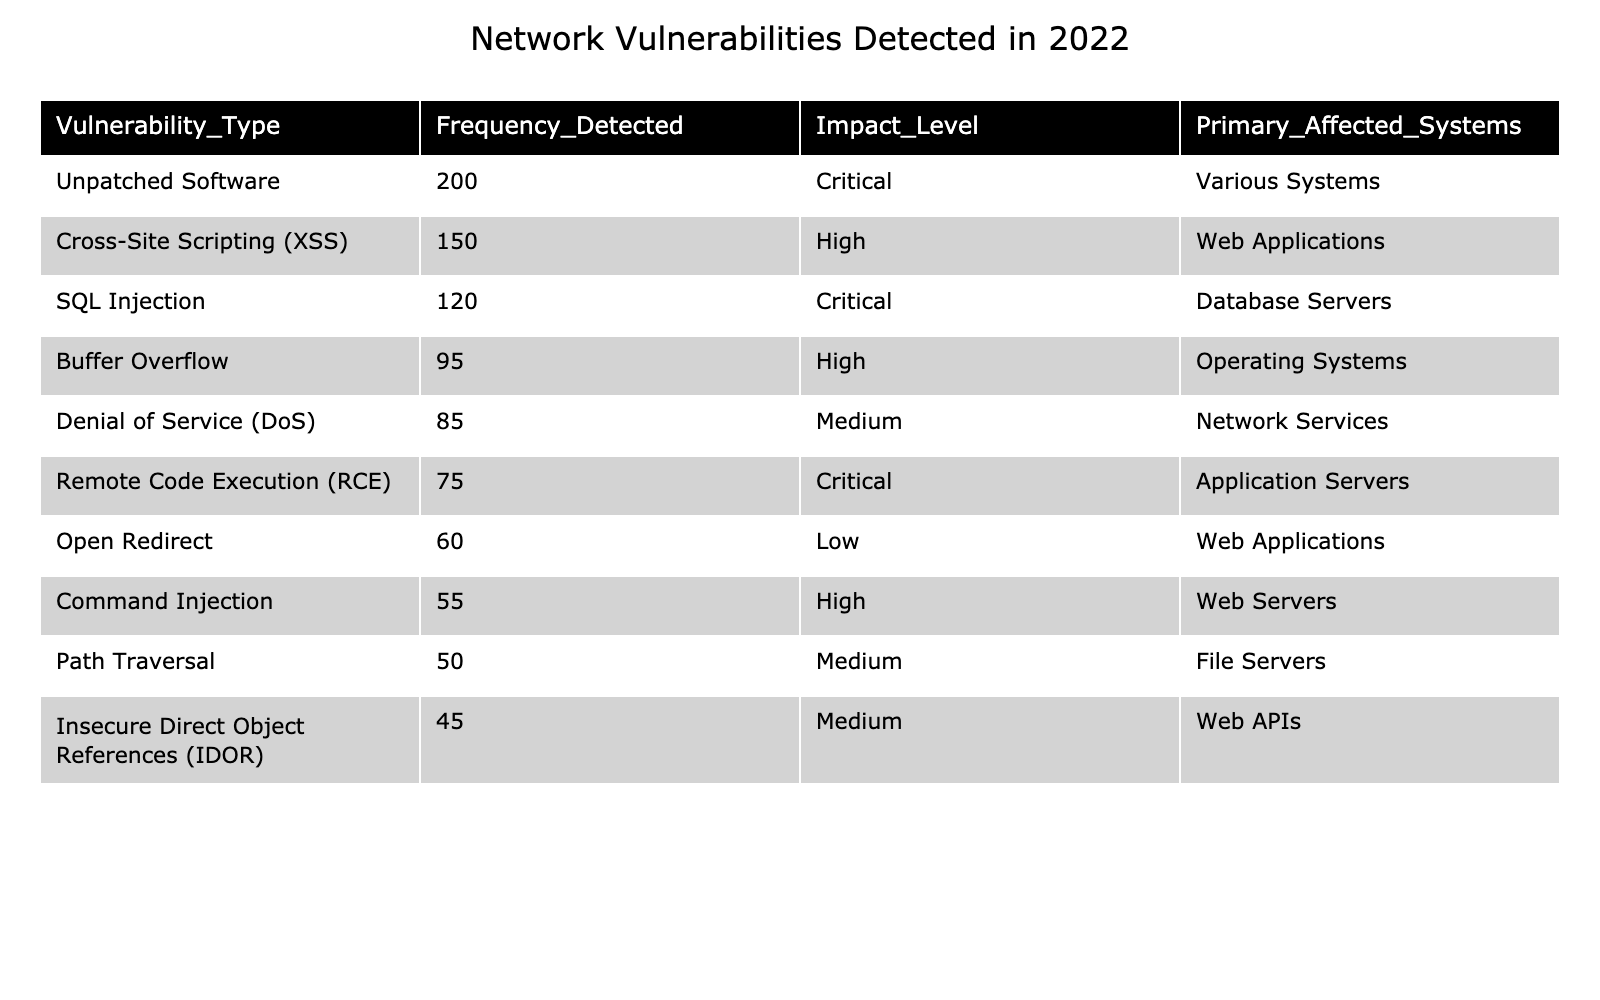What is the type of vulnerability with the highest frequency detected? The highest frequency detected in the table is for "Unpatched Software" with a count of 200. This can be identified by looking at the "Frequency_Detected" column.
Answer: Unpatched Software How many SQL Injection vulnerabilities were detected? The table directly shows that the frequency of SQL Injection vulnerabilities detected is 120.
Answer: 120 What is the average frequency of high-impact vulnerabilities? The high-impact vulnerabilities are XSS (150), Buffer Overflow (95), and Command Injection (55). The total is 150 + 95 + 55 = 300. The average is then 300/3 = 100.
Answer: 100 Is there any vulnerability with a low impact level? Yes, "Open Redirect" is identified in the table as having a low impact level. This can be confirmed by checking the "Impact_Level" column for the corresponding frequency.
Answer: Yes How many more vulnerabilities were detected for Unpatched Software compared to Denial of Service? "Unpatched Software" had 200 detections while "Denial of Service" had 85. The difference is 200 - 85 = 115.
Answer: 115 What proportion of vulnerabilities detected are critical? The critical vulnerabilities are SQL Injection (120), Remote Code Execution (75), and Unpatched Software (200), totaling 395. The total number of vulnerabilities is 200 + 150 + 120 + 95 + 85 + 75 + 60 + 55 + 50 + 45 = 975. The proportion is 395/975 ≈ 0.405, or about 40.5%.
Answer: Approximately 40.5% Which type of vulnerability is primarily affecting web applications? The types of vulnerabilities affecting web applications are "Cross-Site Scripting (XSS)" and "Open Redirect". The presence of these entries in the "Primary_Affected_Systems" column confirms this.
Answer: Cross-Site Scripting (XSS) and Open Redirect What is the total frequency of medium-impact vulnerabilities detected? The medium-impact vulnerabilities listed are Denial of Service (85), Path Traversal (50), and Insecure Direct Object References (45). Their total frequency is 85 + 50 + 45 = 180.
Answer: 180 Which impact level has the lowest total count of detected vulnerabilities? The "Low" impact level has only "Open Redirect" with a frequency of 60. By examining the "Impact_Level" and "Frequency_Detected", this is clear.
Answer: Low What is the difference between the highest and lowest frequency detected among all vulnerabilities? The highest frequency is for "Unpatched Software" (200) and the lowest is for "Insecure Direct Object References" (45). The difference is 200 - 45 = 155.
Answer: 155 